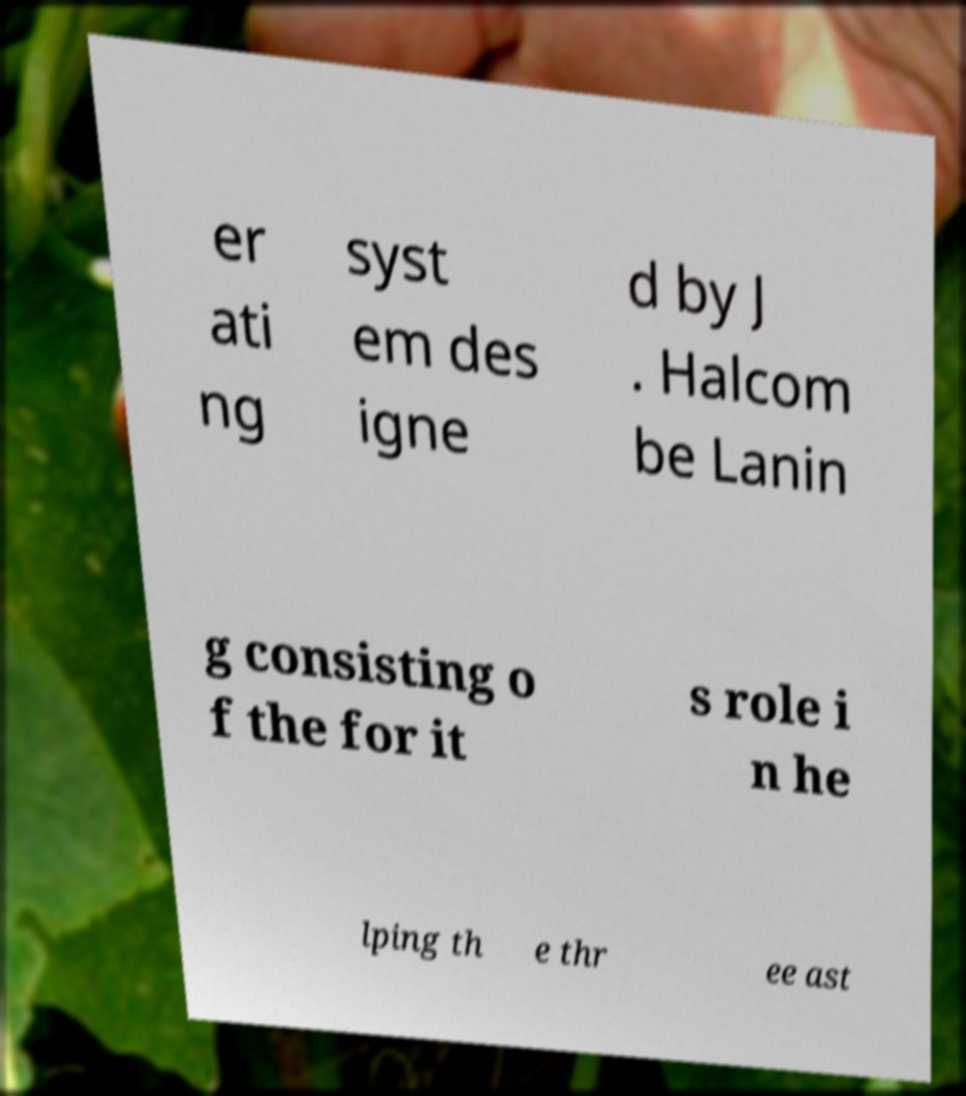I need the written content from this picture converted into text. Can you do that? er ati ng syst em des igne d by J . Halcom be Lanin g consisting o f the for it s role i n he lping th e thr ee ast 